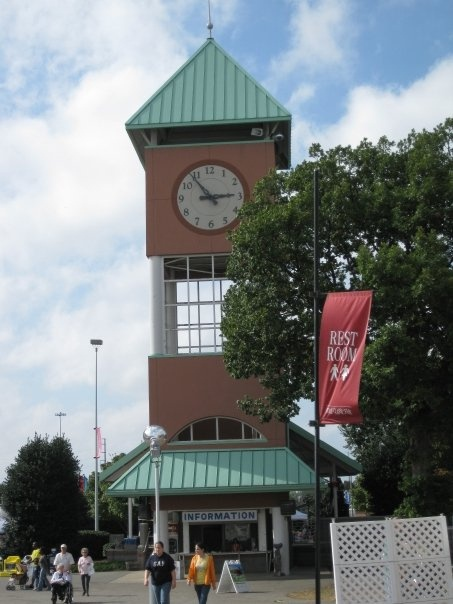Describe the objects in this image and their specific colors. I can see clock in lightgray, gray, maroon, and black tones, people in lightgray, black, gray, and darkgray tones, people in lightgray, black, maroon, and gray tones, people in lightgray, black, gray, darkgray, and lavender tones, and people in lightgray, gray, darkgray, and black tones in this image. 